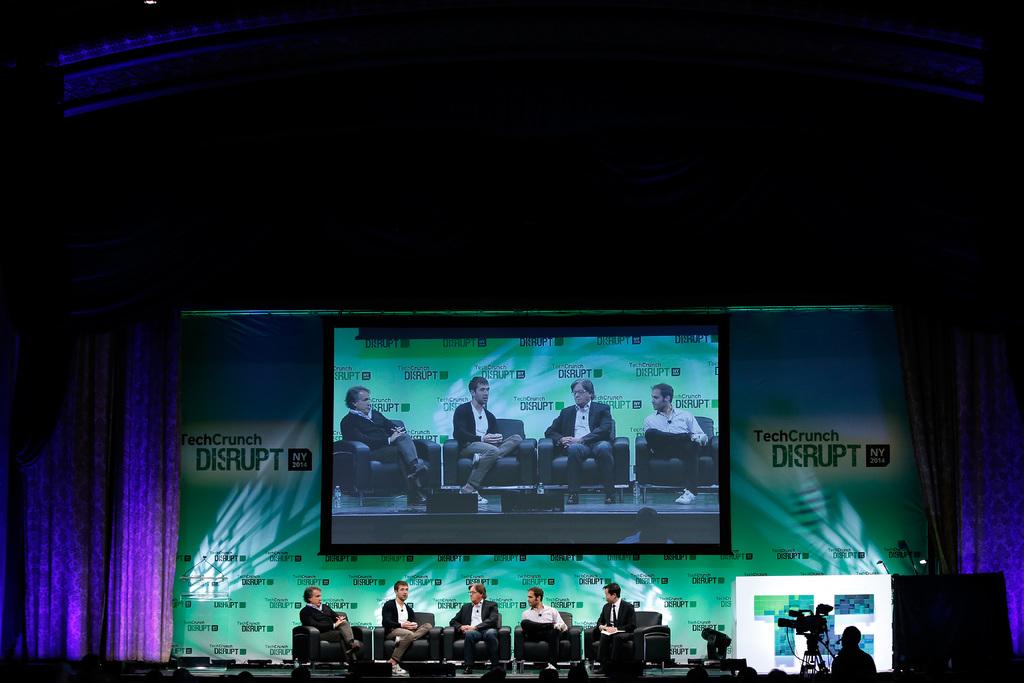What state is the event being held in?
Your answer should be compact. New york. Who sponsors this forum?
Keep it short and to the point. Techcrunch. 